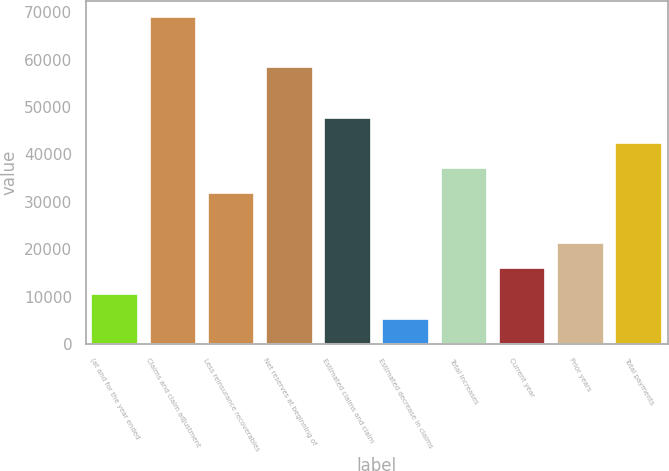Convert chart to OTSL. <chart><loc_0><loc_0><loc_500><loc_500><bar_chart><fcel>(at and for the year ended<fcel>Claims and claim adjustment<fcel>Less reinsurance recoverables<fcel>Net reserves at beginning of<fcel>Estimated claims and claim<fcel>Estimated decrease in claims<fcel>Total increases<fcel>Current year<fcel>Prior years<fcel>Total payments<nl><fcel>10630<fcel>68963<fcel>31842<fcel>58357<fcel>47751<fcel>5327<fcel>37145<fcel>15933<fcel>21236<fcel>42448<nl></chart> 